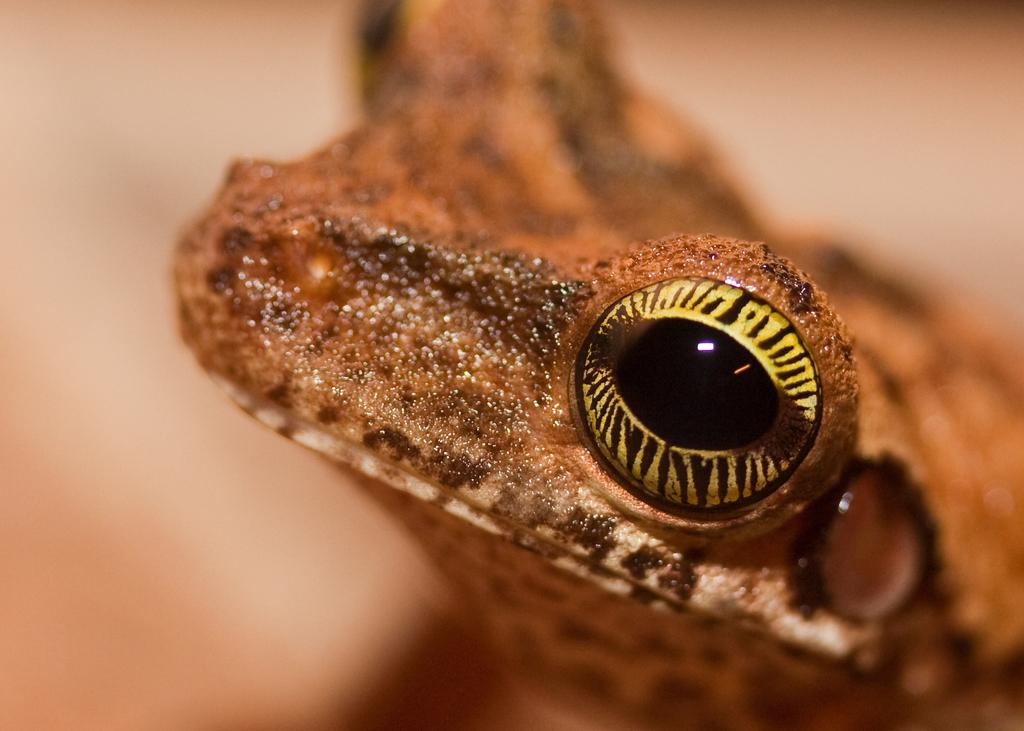What type of animal is in the image? There is a reptile in the image. What part of the reptile is visible in the image? The face of the reptile is visible in the image. Can you describe the background of the image? The background of the image looks blurry. What color is the eye of the reptile in the image? The facts provided do not mention the color of the reptile's eye, so it cannot be determined from the image. What suggestion does the reptile make in the image? The image does not depict the reptile making any suggestions, as it is a still image. 